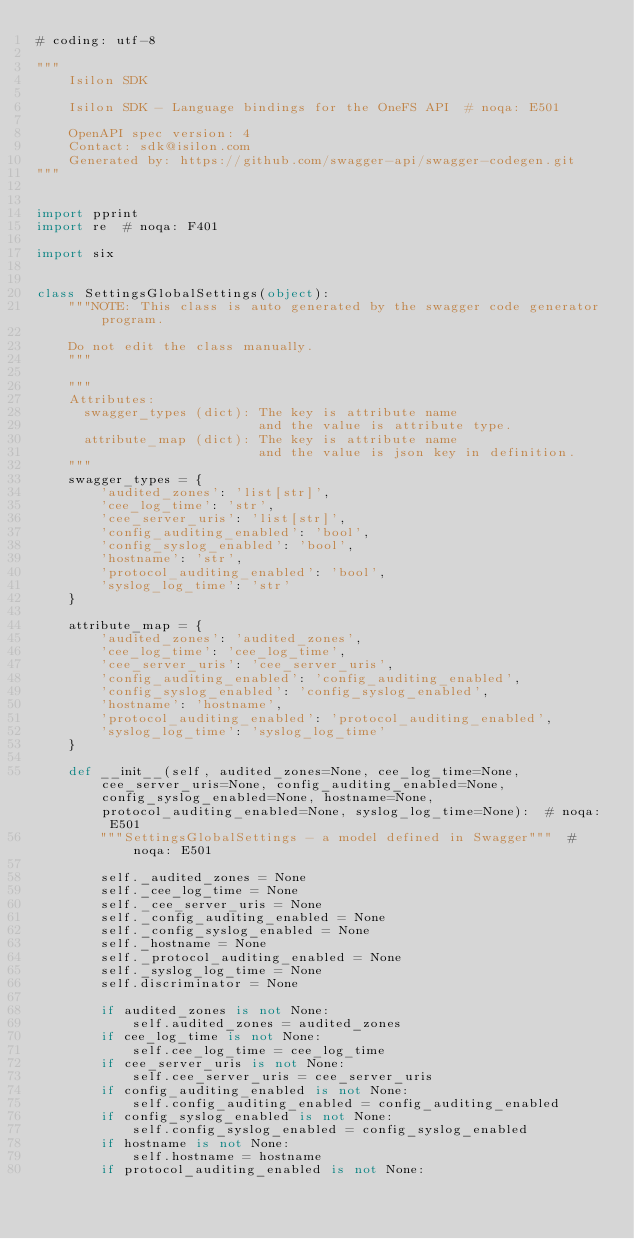Convert code to text. <code><loc_0><loc_0><loc_500><loc_500><_Python_># coding: utf-8

"""
    Isilon SDK

    Isilon SDK - Language bindings for the OneFS API  # noqa: E501

    OpenAPI spec version: 4
    Contact: sdk@isilon.com
    Generated by: https://github.com/swagger-api/swagger-codegen.git
"""


import pprint
import re  # noqa: F401

import six


class SettingsGlobalSettings(object):
    """NOTE: This class is auto generated by the swagger code generator program.

    Do not edit the class manually.
    """

    """
    Attributes:
      swagger_types (dict): The key is attribute name
                            and the value is attribute type.
      attribute_map (dict): The key is attribute name
                            and the value is json key in definition.
    """
    swagger_types = {
        'audited_zones': 'list[str]',
        'cee_log_time': 'str',
        'cee_server_uris': 'list[str]',
        'config_auditing_enabled': 'bool',
        'config_syslog_enabled': 'bool',
        'hostname': 'str',
        'protocol_auditing_enabled': 'bool',
        'syslog_log_time': 'str'
    }

    attribute_map = {
        'audited_zones': 'audited_zones',
        'cee_log_time': 'cee_log_time',
        'cee_server_uris': 'cee_server_uris',
        'config_auditing_enabled': 'config_auditing_enabled',
        'config_syslog_enabled': 'config_syslog_enabled',
        'hostname': 'hostname',
        'protocol_auditing_enabled': 'protocol_auditing_enabled',
        'syslog_log_time': 'syslog_log_time'
    }

    def __init__(self, audited_zones=None, cee_log_time=None, cee_server_uris=None, config_auditing_enabled=None, config_syslog_enabled=None, hostname=None, protocol_auditing_enabled=None, syslog_log_time=None):  # noqa: E501
        """SettingsGlobalSettings - a model defined in Swagger"""  # noqa: E501

        self._audited_zones = None
        self._cee_log_time = None
        self._cee_server_uris = None
        self._config_auditing_enabled = None
        self._config_syslog_enabled = None
        self._hostname = None
        self._protocol_auditing_enabled = None
        self._syslog_log_time = None
        self.discriminator = None

        if audited_zones is not None:
            self.audited_zones = audited_zones
        if cee_log_time is not None:
            self.cee_log_time = cee_log_time
        if cee_server_uris is not None:
            self.cee_server_uris = cee_server_uris
        if config_auditing_enabled is not None:
            self.config_auditing_enabled = config_auditing_enabled
        if config_syslog_enabled is not None:
            self.config_syslog_enabled = config_syslog_enabled
        if hostname is not None:
            self.hostname = hostname
        if protocol_auditing_enabled is not None:</code> 